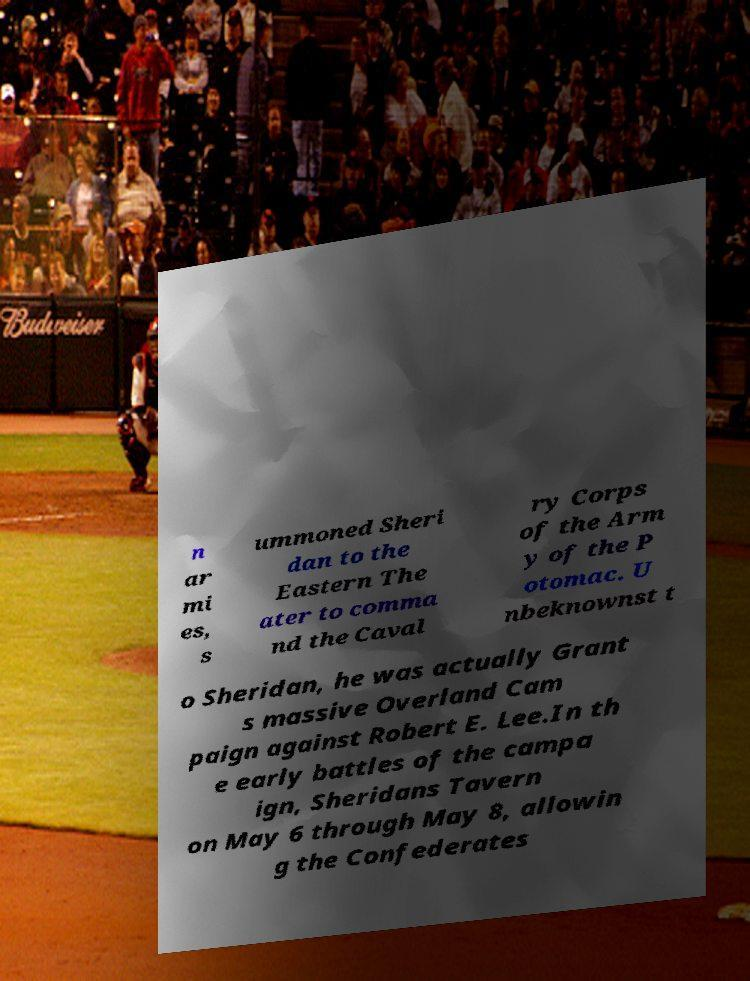Could you assist in decoding the text presented in this image and type it out clearly? n ar mi es, s ummoned Sheri dan to the Eastern The ater to comma nd the Caval ry Corps of the Arm y of the P otomac. U nbeknownst t o Sheridan, he was actually Grant s massive Overland Cam paign against Robert E. Lee.In th e early battles of the campa ign, Sheridans Tavern on May 6 through May 8, allowin g the Confederates 